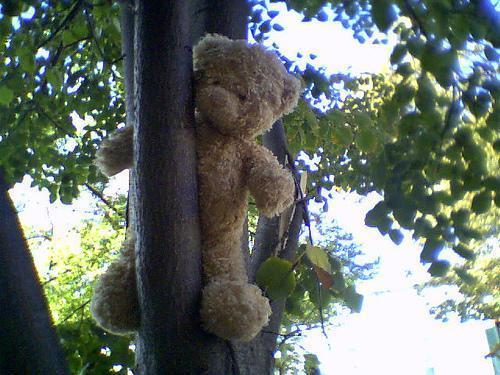How many teddy bears can you see?
Give a very brief answer. 1. How many windows on this airplane are touched by red or orange paint?
Give a very brief answer. 0. 